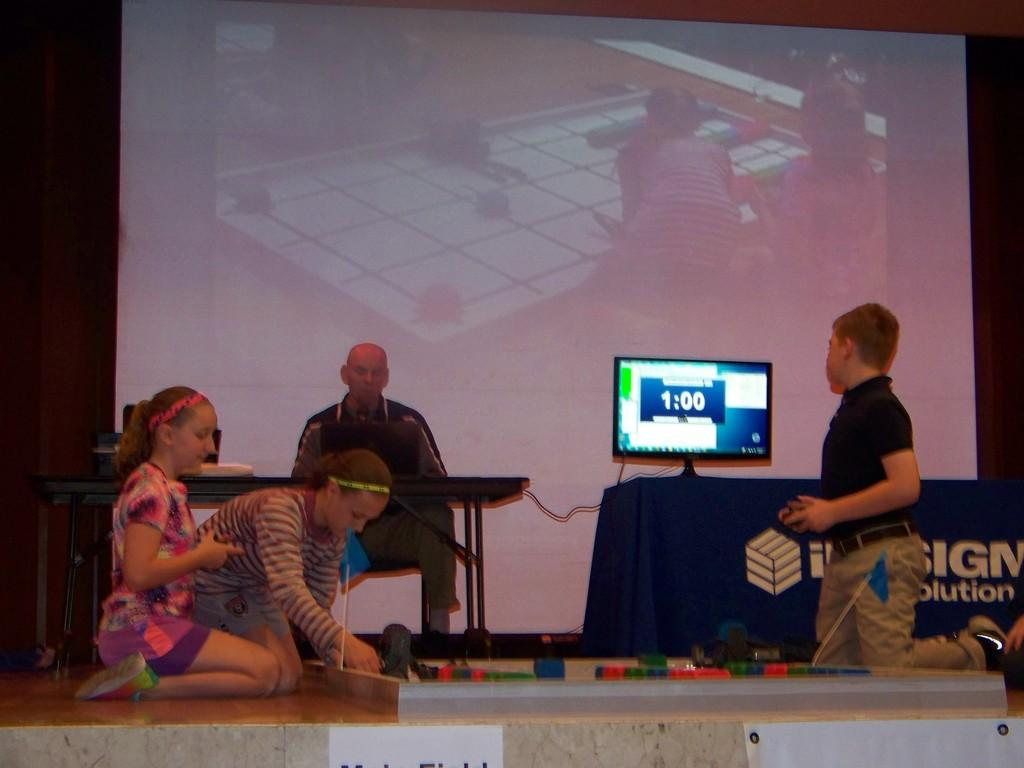<image>
Write a terse but informative summary of the picture. A bunch of kids playing with stuff on a stage including a computer with a monitor display 1:00. 